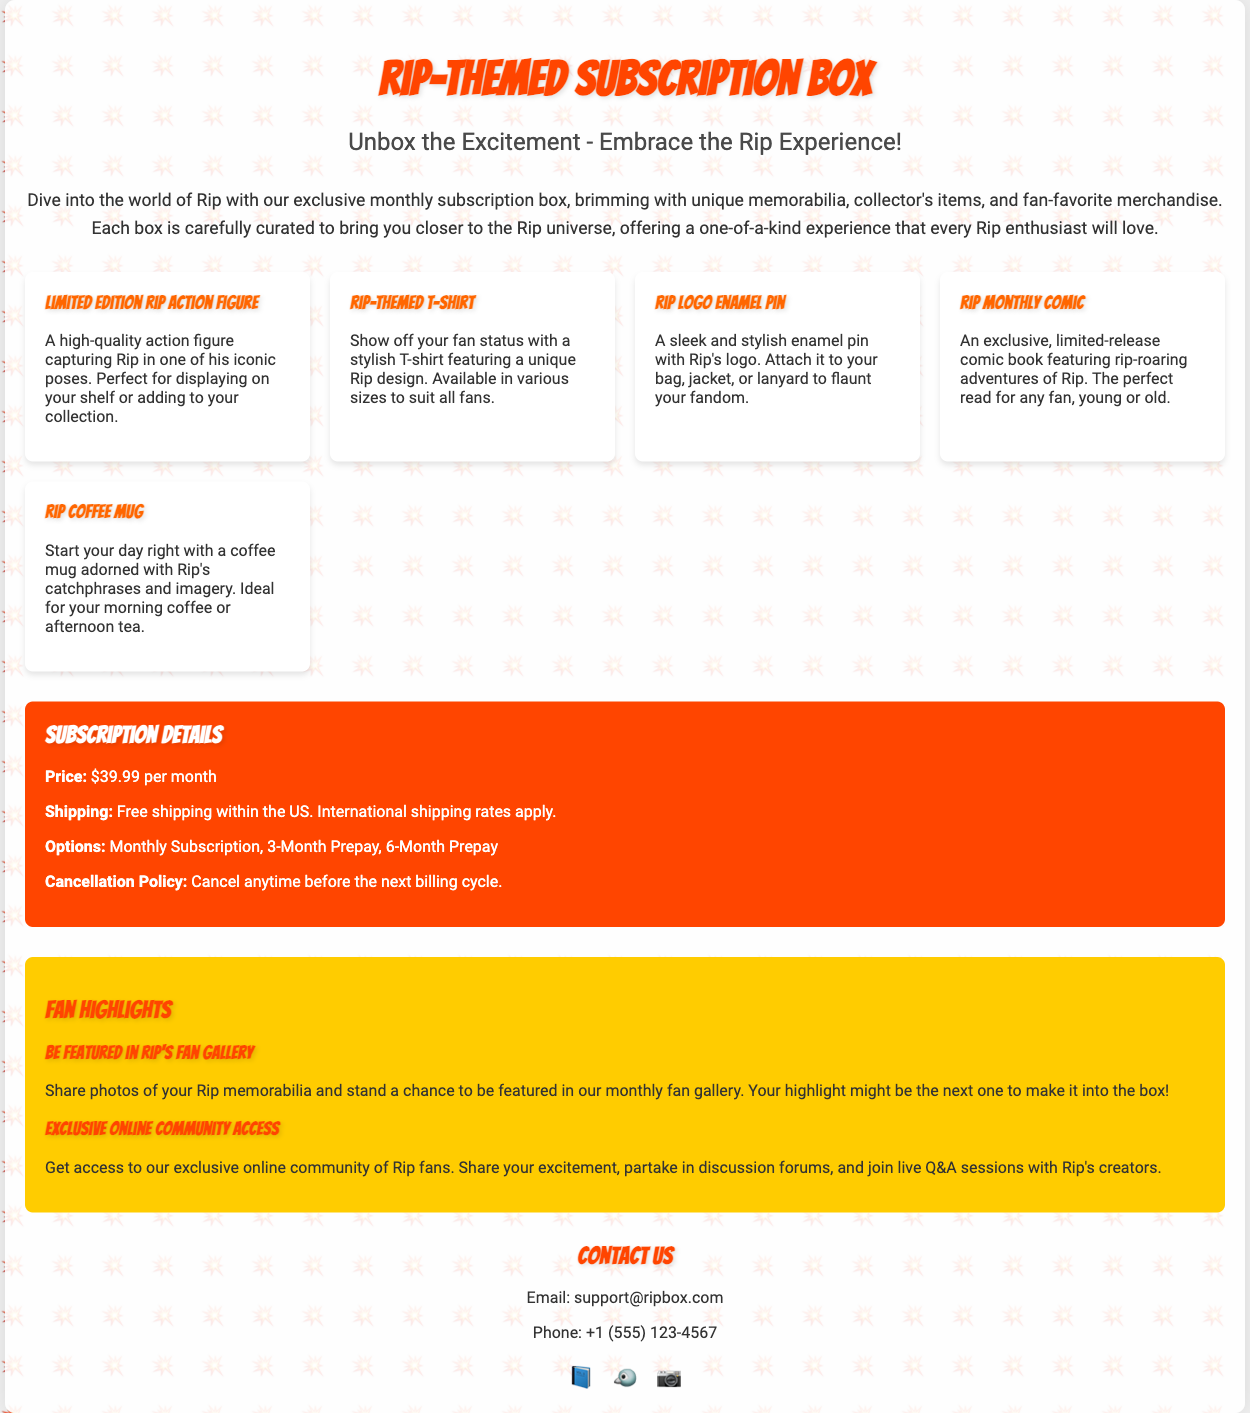What is the price of the subscription box? The price of the subscription box is listed in the subscription details section of the document.
Answer: $39.99 per month What type of pin is included in the subscription box? The document describes an item included in the box, specifically mentioning its type and association.
Answer: Enamel pin What are the shipping options for the subscription box? The document outlines the details regarding shipping and whether it is free or not within the specified region.
Answer: Free shipping within the US How many items are listed in the content grid? The document displays a content grid featuring distinct items, and counting them will yield the total.
Answer: 5 items What is one of the benefits of being part of the exclusive online community? The document mentions various benefits related to the online community, highlighting one of them specifically.
Answer: Join live Q&A sessions What should a customer do if they wish to cancel their subscription? The cancellation policy is stated in the subscription details, indicating what actions need to be taken.
Answer: Cancel anytime before the next billing cycle What type of T-shirt is included in the subscription box? The description section specifies the nature of the T-shirt offered within the box, including its design style.
Answer: Stylish T-shirt What kind of coffee mug is mentioned in the document? The description in the content grid specifies the attributes of the coffee mug offered.
Answer: Adorned with Rip's catchphrases and imagery How can fans be featured in Rip's Fan Gallery? The document outlines a specific action that fans need to take to get featured, which is clearly mentioned.
Answer: Share photos of your Rip memorabilia 